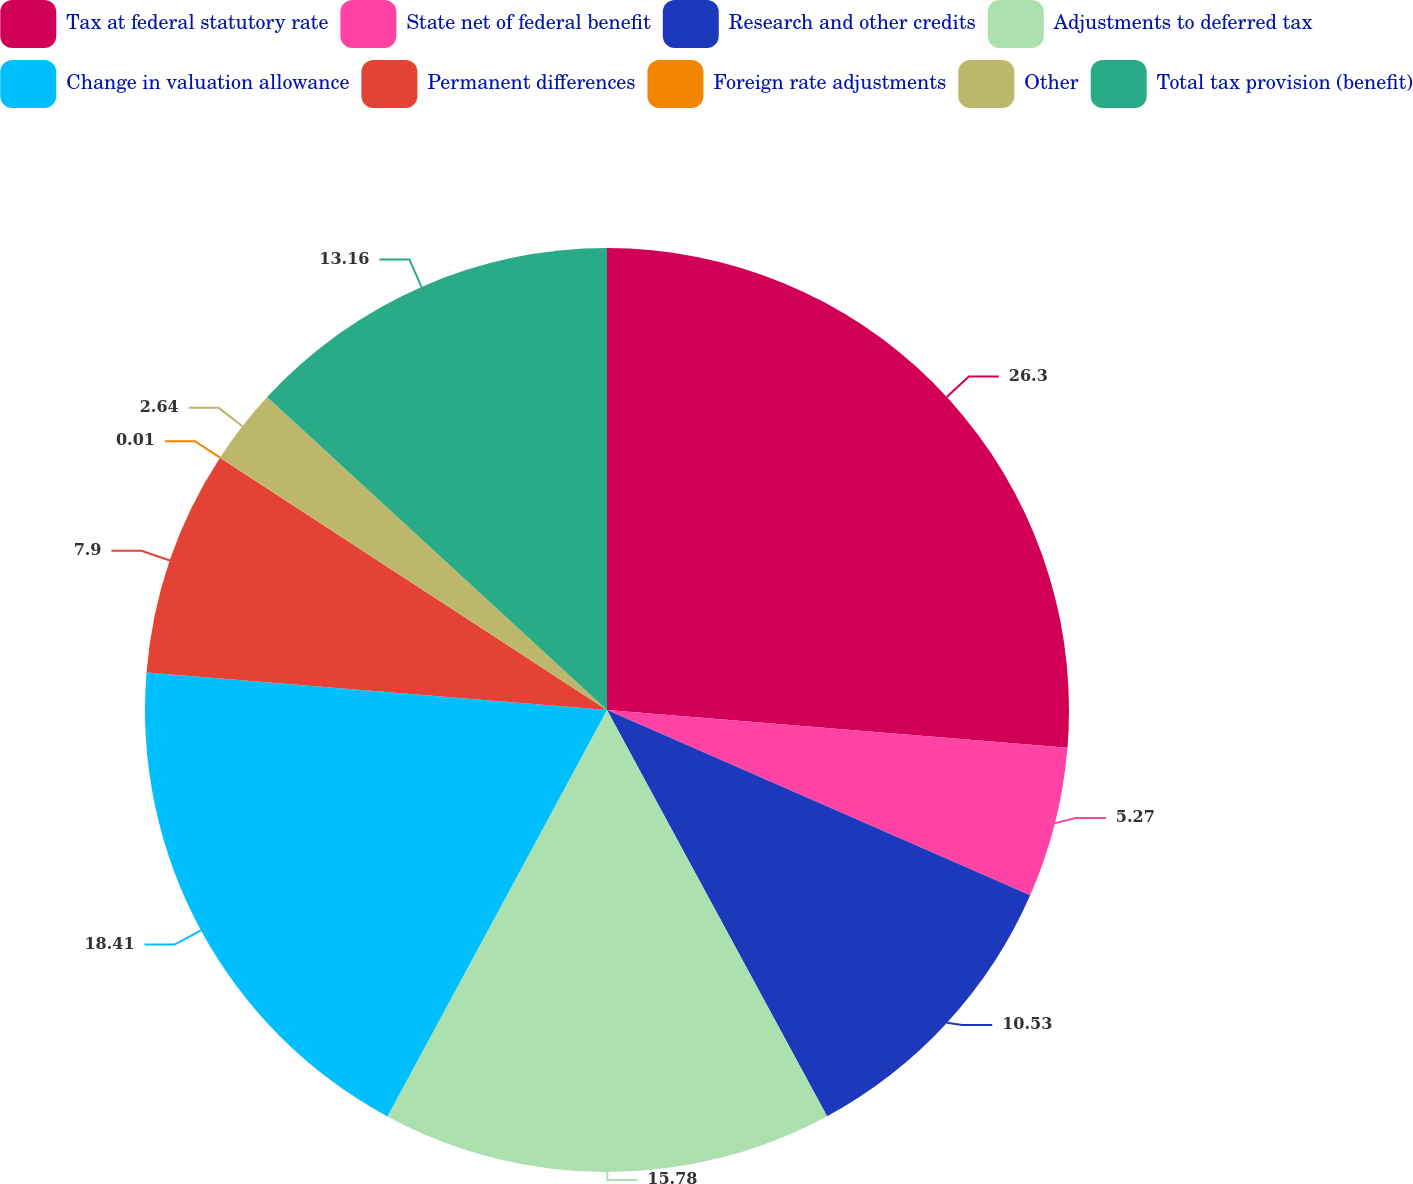Convert chart. <chart><loc_0><loc_0><loc_500><loc_500><pie_chart><fcel>Tax at federal statutory rate<fcel>State net of federal benefit<fcel>Research and other credits<fcel>Adjustments to deferred tax<fcel>Change in valuation allowance<fcel>Permanent differences<fcel>Foreign rate adjustments<fcel>Other<fcel>Total tax provision (benefit)<nl><fcel>26.31%<fcel>5.27%<fcel>10.53%<fcel>15.79%<fcel>18.42%<fcel>7.9%<fcel>0.01%<fcel>2.64%<fcel>13.16%<nl></chart> 